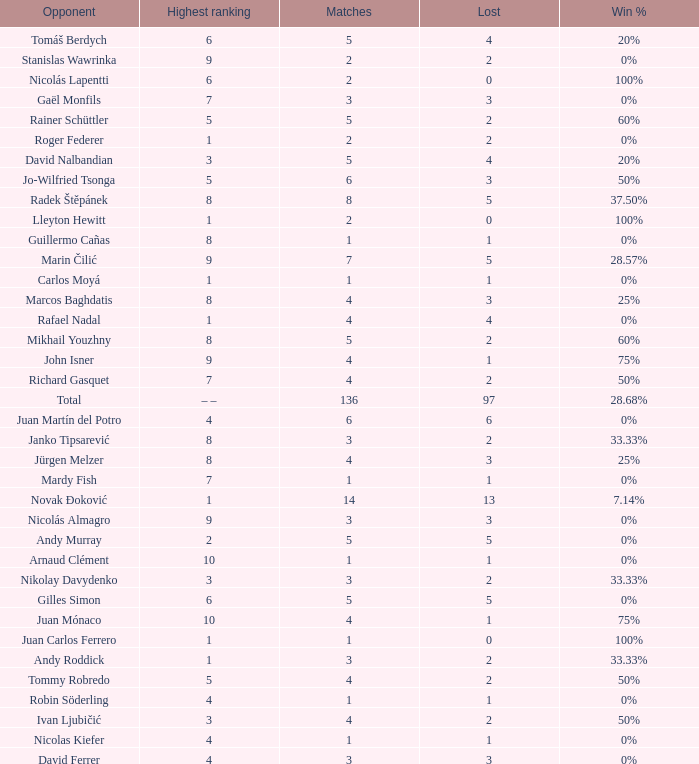Write the full table. {'header': ['Opponent', 'Highest ranking', 'Matches', 'Lost', 'Win %'], 'rows': [['Tomáš Berdych', '6', '5', '4', '20%'], ['Stanislas Wawrinka', '9', '2', '2', '0%'], ['Nicolás Lapentti', '6', '2', '0', '100%'], ['Gaël Monfils', '7', '3', '3', '0%'], ['Rainer Schüttler', '5', '5', '2', '60%'], ['Roger Federer', '1', '2', '2', '0%'], ['David Nalbandian', '3', '5', '4', '20%'], ['Jo-Wilfried Tsonga', '5', '6', '3', '50%'], ['Radek Štěpánek', '8', '8', '5', '37.50%'], ['Lleyton Hewitt', '1', '2', '0', '100%'], ['Guillermo Cañas', '8', '1', '1', '0%'], ['Marin Čilić', '9', '7', '5', '28.57%'], ['Carlos Moyá', '1', '1', '1', '0%'], ['Marcos Baghdatis', '8', '4', '3', '25%'], ['Rafael Nadal', '1', '4', '4', '0%'], ['Mikhail Youzhny', '8', '5', '2', '60%'], ['John Isner', '9', '4', '1', '75%'], ['Richard Gasquet', '7', '4', '2', '50%'], ['Total', '– –', '136', '97', '28.68%'], ['Juan Martín del Potro', '4', '6', '6', '0%'], ['Janko Tipsarević', '8', '3', '2', '33.33%'], ['Jürgen Melzer', '8', '4', '3', '25%'], ['Mardy Fish', '7', '1', '1', '0%'], ['Novak Đoković', '1', '14', '13', '7.14%'], ['Nicolás Almagro', '9', '3', '3', '0%'], ['Andy Murray', '2', '5', '5', '0%'], ['Arnaud Clément', '10', '1', '1', '0%'], ['Nikolay Davydenko', '3', '3', '2', '33.33%'], ['Gilles Simon', '6', '5', '5', '0%'], ['Juan Mónaco', '10', '4', '1', '75%'], ['Juan Carlos Ferrero', '1', '1', '0', '100%'], ['Andy Roddick', '1', '3', '2', '33.33%'], ['Tommy Robredo', '5', '4', '2', '50%'], ['Robin Söderling', '4', '1', '1', '0%'], ['Ivan Ljubičić', '3', '4', '2', '50%'], ['Nicolas Kiefer', '4', '1', '1', '0%'], ['David Ferrer', '4', '3', '3', '0%']]} What is the total number of Lost for the Highest Ranking of – –? 1.0. 